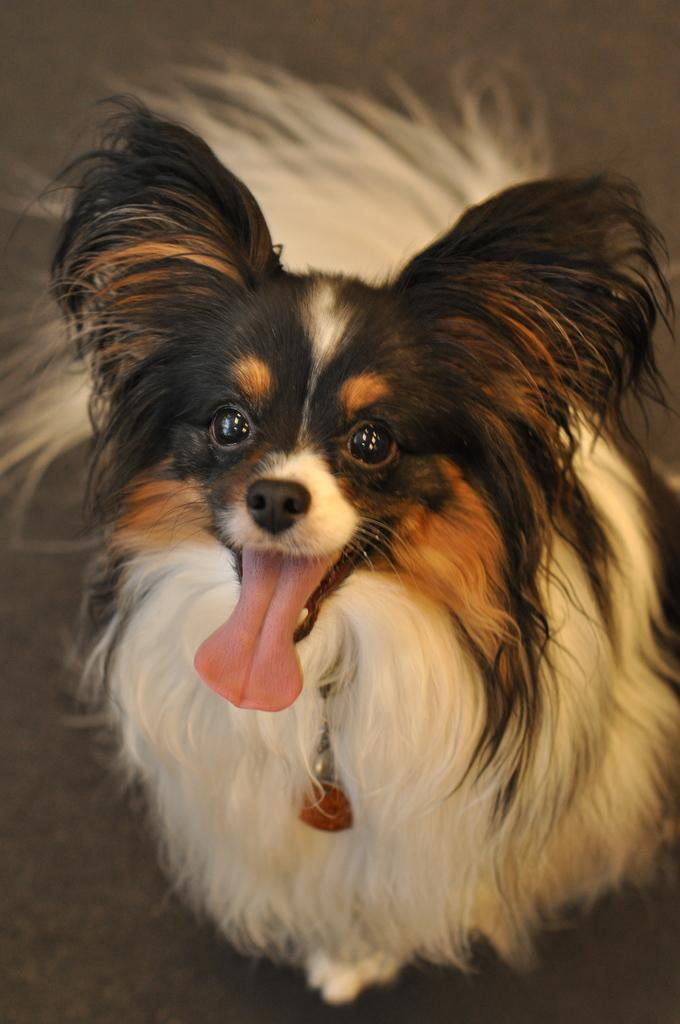What type of animal is in the picture? There is a dog in the picture. What is the dog doing in the picture? The dog is standing on the ground. How many clocks are visible in the picture? There are no clocks visible in the picture; it only features a dog standing on the ground. 